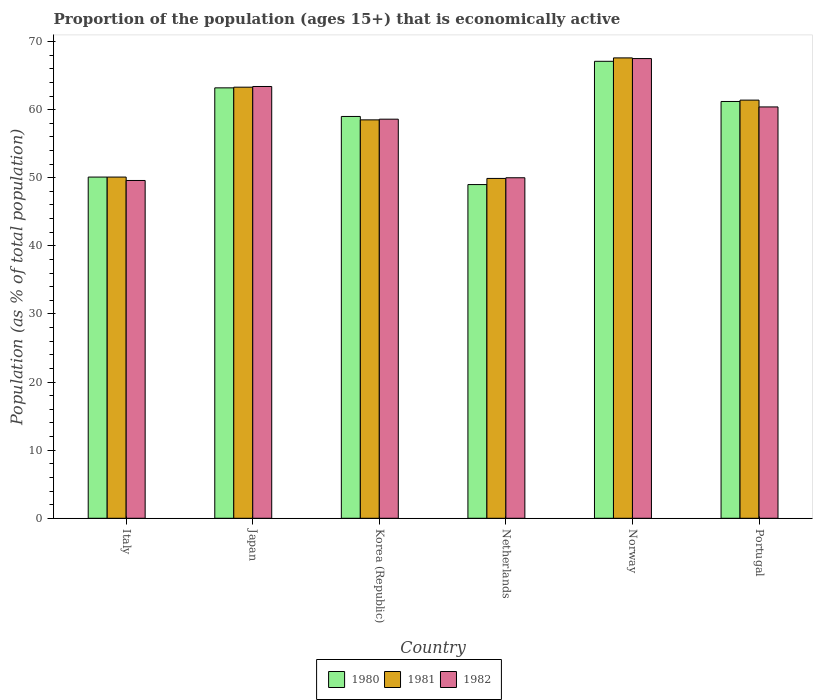How many groups of bars are there?
Offer a very short reply. 6. Are the number of bars on each tick of the X-axis equal?
Your answer should be compact. Yes. How many bars are there on the 1st tick from the left?
Provide a short and direct response. 3. What is the label of the 3rd group of bars from the left?
Ensure brevity in your answer.  Korea (Republic). In how many cases, is the number of bars for a given country not equal to the number of legend labels?
Provide a succinct answer. 0. Across all countries, what is the maximum proportion of the population that is economically active in 1982?
Offer a very short reply. 67.5. Across all countries, what is the minimum proportion of the population that is economically active in 1981?
Offer a very short reply. 49.9. What is the total proportion of the population that is economically active in 1982 in the graph?
Ensure brevity in your answer.  349.5. What is the difference between the proportion of the population that is economically active in 1981 in Italy and that in Netherlands?
Provide a short and direct response. 0.2. What is the difference between the proportion of the population that is economically active in 1982 in Netherlands and the proportion of the population that is economically active in 1980 in Norway?
Provide a succinct answer. -17.1. What is the average proportion of the population that is economically active in 1982 per country?
Your answer should be very brief. 58.25. What is the difference between the proportion of the population that is economically active of/in 1980 and proportion of the population that is economically active of/in 1981 in Japan?
Ensure brevity in your answer.  -0.1. In how many countries, is the proportion of the population that is economically active in 1982 greater than 44 %?
Make the answer very short. 6. What is the ratio of the proportion of the population that is economically active in 1982 in Italy to that in Norway?
Keep it short and to the point. 0.73. Is the difference between the proportion of the population that is economically active in 1980 in Italy and Netherlands greater than the difference between the proportion of the population that is economically active in 1981 in Italy and Netherlands?
Your answer should be very brief. Yes. What is the difference between the highest and the second highest proportion of the population that is economically active in 1980?
Provide a short and direct response. 5.9. What is the difference between the highest and the lowest proportion of the population that is economically active in 1982?
Keep it short and to the point. 17.9. Is it the case that in every country, the sum of the proportion of the population that is economically active in 1981 and proportion of the population that is economically active in 1982 is greater than the proportion of the population that is economically active in 1980?
Make the answer very short. Yes. How many bars are there?
Your response must be concise. 18. How many countries are there in the graph?
Your answer should be compact. 6. Are the values on the major ticks of Y-axis written in scientific E-notation?
Your answer should be compact. No. Does the graph contain any zero values?
Offer a terse response. No. Does the graph contain grids?
Provide a short and direct response. No. Where does the legend appear in the graph?
Keep it short and to the point. Bottom center. How many legend labels are there?
Your response must be concise. 3. How are the legend labels stacked?
Make the answer very short. Horizontal. What is the title of the graph?
Offer a terse response. Proportion of the population (ages 15+) that is economically active. What is the label or title of the X-axis?
Give a very brief answer. Country. What is the label or title of the Y-axis?
Your answer should be compact. Population (as % of total population). What is the Population (as % of total population) in 1980 in Italy?
Make the answer very short. 50.1. What is the Population (as % of total population) of 1981 in Italy?
Provide a succinct answer. 50.1. What is the Population (as % of total population) in 1982 in Italy?
Ensure brevity in your answer.  49.6. What is the Population (as % of total population) in 1980 in Japan?
Keep it short and to the point. 63.2. What is the Population (as % of total population) in 1981 in Japan?
Offer a terse response. 63.3. What is the Population (as % of total population) in 1982 in Japan?
Offer a very short reply. 63.4. What is the Population (as % of total population) in 1981 in Korea (Republic)?
Offer a very short reply. 58.5. What is the Population (as % of total population) in 1982 in Korea (Republic)?
Offer a terse response. 58.6. What is the Population (as % of total population) in 1980 in Netherlands?
Ensure brevity in your answer.  49. What is the Population (as % of total population) of 1981 in Netherlands?
Ensure brevity in your answer.  49.9. What is the Population (as % of total population) of 1980 in Norway?
Your answer should be compact. 67.1. What is the Population (as % of total population) in 1981 in Norway?
Your response must be concise. 67.6. What is the Population (as % of total population) in 1982 in Norway?
Give a very brief answer. 67.5. What is the Population (as % of total population) in 1980 in Portugal?
Give a very brief answer. 61.2. What is the Population (as % of total population) of 1981 in Portugal?
Make the answer very short. 61.4. What is the Population (as % of total population) in 1982 in Portugal?
Offer a terse response. 60.4. Across all countries, what is the maximum Population (as % of total population) in 1980?
Offer a very short reply. 67.1. Across all countries, what is the maximum Population (as % of total population) in 1981?
Your response must be concise. 67.6. Across all countries, what is the maximum Population (as % of total population) of 1982?
Your answer should be very brief. 67.5. Across all countries, what is the minimum Population (as % of total population) of 1980?
Give a very brief answer. 49. Across all countries, what is the minimum Population (as % of total population) in 1981?
Your answer should be compact. 49.9. Across all countries, what is the minimum Population (as % of total population) in 1982?
Provide a succinct answer. 49.6. What is the total Population (as % of total population) of 1980 in the graph?
Keep it short and to the point. 349.6. What is the total Population (as % of total population) in 1981 in the graph?
Offer a very short reply. 350.8. What is the total Population (as % of total population) of 1982 in the graph?
Keep it short and to the point. 349.5. What is the difference between the Population (as % of total population) of 1980 in Italy and that in Japan?
Keep it short and to the point. -13.1. What is the difference between the Population (as % of total population) in 1981 in Italy and that in Japan?
Provide a succinct answer. -13.2. What is the difference between the Population (as % of total population) of 1982 in Italy and that in Japan?
Ensure brevity in your answer.  -13.8. What is the difference between the Population (as % of total population) of 1981 in Italy and that in Korea (Republic)?
Provide a succinct answer. -8.4. What is the difference between the Population (as % of total population) in 1982 in Italy and that in Korea (Republic)?
Offer a terse response. -9. What is the difference between the Population (as % of total population) in 1980 in Italy and that in Netherlands?
Give a very brief answer. 1.1. What is the difference between the Population (as % of total population) in 1981 in Italy and that in Netherlands?
Your answer should be compact. 0.2. What is the difference between the Population (as % of total population) of 1982 in Italy and that in Netherlands?
Give a very brief answer. -0.4. What is the difference between the Population (as % of total population) in 1981 in Italy and that in Norway?
Your answer should be compact. -17.5. What is the difference between the Population (as % of total population) of 1982 in Italy and that in Norway?
Ensure brevity in your answer.  -17.9. What is the difference between the Population (as % of total population) in 1980 in Italy and that in Portugal?
Give a very brief answer. -11.1. What is the difference between the Population (as % of total population) in 1981 in Italy and that in Portugal?
Offer a terse response. -11.3. What is the difference between the Population (as % of total population) in 1980 in Japan and that in Netherlands?
Give a very brief answer. 14.2. What is the difference between the Population (as % of total population) of 1981 in Japan and that in Netherlands?
Keep it short and to the point. 13.4. What is the difference between the Population (as % of total population) in 1982 in Japan and that in Netherlands?
Provide a succinct answer. 13.4. What is the difference between the Population (as % of total population) in 1981 in Japan and that in Norway?
Your response must be concise. -4.3. What is the difference between the Population (as % of total population) in 1980 in Japan and that in Portugal?
Make the answer very short. 2. What is the difference between the Population (as % of total population) in 1980 in Korea (Republic) and that in Netherlands?
Your answer should be compact. 10. What is the difference between the Population (as % of total population) in 1981 in Korea (Republic) and that in Netherlands?
Your answer should be very brief. 8.6. What is the difference between the Population (as % of total population) of 1982 in Korea (Republic) and that in Netherlands?
Offer a very short reply. 8.6. What is the difference between the Population (as % of total population) in 1981 in Korea (Republic) and that in Norway?
Your answer should be very brief. -9.1. What is the difference between the Population (as % of total population) of 1982 in Korea (Republic) and that in Norway?
Keep it short and to the point. -8.9. What is the difference between the Population (as % of total population) of 1980 in Korea (Republic) and that in Portugal?
Your answer should be very brief. -2.2. What is the difference between the Population (as % of total population) in 1981 in Korea (Republic) and that in Portugal?
Offer a terse response. -2.9. What is the difference between the Population (as % of total population) of 1980 in Netherlands and that in Norway?
Ensure brevity in your answer.  -18.1. What is the difference between the Population (as % of total population) of 1981 in Netherlands and that in Norway?
Your answer should be very brief. -17.7. What is the difference between the Population (as % of total population) in 1982 in Netherlands and that in Norway?
Your answer should be compact. -17.5. What is the difference between the Population (as % of total population) of 1980 in Netherlands and that in Portugal?
Offer a terse response. -12.2. What is the difference between the Population (as % of total population) in 1981 in Netherlands and that in Portugal?
Your answer should be compact. -11.5. What is the difference between the Population (as % of total population) of 1981 in Norway and that in Portugal?
Keep it short and to the point. 6.2. What is the difference between the Population (as % of total population) of 1980 in Italy and the Population (as % of total population) of 1981 in Korea (Republic)?
Offer a very short reply. -8.4. What is the difference between the Population (as % of total population) in 1980 in Italy and the Population (as % of total population) in 1981 in Netherlands?
Offer a very short reply. 0.2. What is the difference between the Population (as % of total population) in 1980 in Italy and the Population (as % of total population) in 1981 in Norway?
Make the answer very short. -17.5. What is the difference between the Population (as % of total population) of 1980 in Italy and the Population (as % of total population) of 1982 in Norway?
Offer a very short reply. -17.4. What is the difference between the Population (as % of total population) of 1981 in Italy and the Population (as % of total population) of 1982 in Norway?
Keep it short and to the point. -17.4. What is the difference between the Population (as % of total population) of 1980 in Italy and the Population (as % of total population) of 1981 in Portugal?
Make the answer very short. -11.3. What is the difference between the Population (as % of total population) in 1980 in Japan and the Population (as % of total population) in 1981 in Korea (Republic)?
Provide a succinct answer. 4.7. What is the difference between the Population (as % of total population) of 1981 in Japan and the Population (as % of total population) of 1982 in Netherlands?
Your answer should be compact. 13.3. What is the difference between the Population (as % of total population) of 1980 in Japan and the Population (as % of total population) of 1982 in Norway?
Ensure brevity in your answer.  -4.3. What is the difference between the Population (as % of total population) in 1981 in Japan and the Population (as % of total population) in 1982 in Portugal?
Give a very brief answer. 2.9. What is the difference between the Population (as % of total population) in 1980 in Korea (Republic) and the Population (as % of total population) in 1981 in Netherlands?
Offer a terse response. 9.1. What is the difference between the Population (as % of total population) in 1980 in Korea (Republic) and the Population (as % of total population) in 1982 in Netherlands?
Offer a terse response. 9. What is the difference between the Population (as % of total population) of 1981 in Korea (Republic) and the Population (as % of total population) of 1982 in Netherlands?
Provide a short and direct response. 8.5. What is the difference between the Population (as % of total population) in 1980 in Korea (Republic) and the Population (as % of total population) in 1981 in Portugal?
Keep it short and to the point. -2.4. What is the difference between the Population (as % of total population) of 1981 in Korea (Republic) and the Population (as % of total population) of 1982 in Portugal?
Your answer should be compact. -1.9. What is the difference between the Population (as % of total population) in 1980 in Netherlands and the Population (as % of total population) in 1981 in Norway?
Provide a short and direct response. -18.6. What is the difference between the Population (as % of total population) of 1980 in Netherlands and the Population (as % of total population) of 1982 in Norway?
Offer a very short reply. -18.5. What is the difference between the Population (as % of total population) in 1981 in Netherlands and the Population (as % of total population) in 1982 in Norway?
Provide a succinct answer. -17.6. What is the difference between the Population (as % of total population) of 1980 in Netherlands and the Population (as % of total population) of 1981 in Portugal?
Make the answer very short. -12.4. What is the difference between the Population (as % of total population) in 1981 in Netherlands and the Population (as % of total population) in 1982 in Portugal?
Keep it short and to the point. -10.5. What is the difference between the Population (as % of total population) of 1981 in Norway and the Population (as % of total population) of 1982 in Portugal?
Your response must be concise. 7.2. What is the average Population (as % of total population) in 1980 per country?
Your answer should be compact. 58.27. What is the average Population (as % of total population) of 1981 per country?
Your response must be concise. 58.47. What is the average Population (as % of total population) in 1982 per country?
Keep it short and to the point. 58.25. What is the difference between the Population (as % of total population) in 1980 and Population (as % of total population) in 1982 in Italy?
Offer a very short reply. 0.5. What is the difference between the Population (as % of total population) of 1980 and Population (as % of total population) of 1981 in Japan?
Your response must be concise. -0.1. What is the difference between the Population (as % of total population) of 1981 and Population (as % of total population) of 1982 in Japan?
Give a very brief answer. -0.1. What is the difference between the Population (as % of total population) of 1980 and Population (as % of total population) of 1981 in Korea (Republic)?
Your answer should be compact. 0.5. What is the difference between the Population (as % of total population) of 1981 and Population (as % of total population) of 1982 in Korea (Republic)?
Your answer should be very brief. -0.1. What is the difference between the Population (as % of total population) in 1980 and Population (as % of total population) in 1981 in Netherlands?
Give a very brief answer. -0.9. What is the difference between the Population (as % of total population) in 1981 and Population (as % of total population) in 1982 in Netherlands?
Make the answer very short. -0.1. What is the difference between the Population (as % of total population) of 1980 and Population (as % of total population) of 1982 in Norway?
Your response must be concise. -0.4. What is the difference between the Population (as % of total population) in 1980 and Population (as % of total population) in 1982 in Portugal?
Offer a terse response. 0.8. What is the difference between the Population (as % of total population) of 1981 and Population (as % of total population) of 1982 in Portugal?
Offer a terse response. 1. What is the ratio of the Population (as % of total population) in 1980 in Italy to that in Japan?
Your answer should be very brief. 0.79. What is the ratio of the Population (as % of total population) in 1981 in Italy to that in Japan?
Provide a short and direct response. 0.79. What is the ratio of the Population (as % of total population) in 1982 in Italy to that in Japan?
Keep it short and to the point. 0.78. What is the ratio of the Population (as % of total population) in 1980 in Italy to that in Korea (Republic)?
Provide a succinct answer. 0.85. What is the ratio of the Population (as % of total population) of 1981 in Italy to that in Korea (Republic)?
Make the answer very short. 0.86. What is the ratio of the Population (as % of total population) of 1982 in Italy to that in Korea (Republic)?
Provide a succinct answer. 0.85. What is the ratio of the Population (as % of total population) in 1980 in Italy to that in Netherlands?
Your answer should be compact. 1.02. What is the ratio of the Population (as % of total population) in 1982 in Italy to that in Netherlands?
Provide a succinct answer. 0.99. What is the ratio of the Population (as % of total population) in 1980 in Italy to that in Norway?
Keep it short and to the point. 0.75. What is the ratio of the Population (as % of total population) in 1981 in Italy to that in Norway?
Your response must be concise. 0.74. What is the ratio of the Population (as % of total population) in 1982 in Italy to that in Norway?
Ensure brevity in your answer.  0.73. What is the ratio of the Population (as % of total population) in 1980 in Italy to that in Portugal?
Your answer should be very brief. 0.82. What is the ratio of the Population (as % of total population) of 1981 in Italy to that in Portugal?
Keep it short and to the point. 0.82. What is the ratio of the Population (as % of total population) in 1982 in Italy to that in Portugal?
Your response must be concise. 0.82. What is the ratio of the Population (as % of total population) in 1980 in Japan to that in Korea (Republic)?
Make the answer very short. 1.07. What is the ratio of the Population (as % of total population) of 1981 in Japan to that in Korea (Republic)?
Keep it short and to the point. 1.08. What is the ratio of the Population (as % of total population) in 1982 in Japan to that in Korea (Republic)?
Provide a succinct answer. 1.08. What is the ratio of the Population (as % of total population) in 1980 in Japan to that in Netherlands?
Provide a short and direct response. 1.29. What is the ratio of the Population (as % of total population) of 1981 in Japan to that in Netherlands?
Make the answer very short. 1.27. What is the ratio of the Population (as % of total population) of 1982 in Japan to that in Netherlands?
Your answer should be very brief. 1.27. What is the ratio of the Population (as % of total population) of 1980 in Japan to that in Norway?
Ensure brevity in your answer.  0.94. What is the ratio of the Population (as % of total population) in 1981 in Japan to that in Norway?
Your response must be concise. 0.94. What is the ratio of the Population (as % of total population) in 1982 in Japan to that in Norway?
Provide a short and direct response. 0.94. What is the ratio of the Population (as % of total population) in 1980 in Japan to that in Portugal?
Ensure brevity in your answer.  1.03. What is the ratio of the Population (as % of total population) of 1981 in Japan to that in Portugal?
Give a very brief answer. 1.03. What is the ratio of the Population (as % of total population) in 1982 in Japan to that in Portugal?
Your answer should be compact. 1.05. What is the ratio of the Population (as % of total population) of 1980 in Korea (Republic) to that in Netherlands?
Offer a very short reply. 1.2. What is the ratio of the Population (as % of total population) in 1981 in Korea (Republic) to that in Netherlands?
Provide a succinct answer. 1.17. What is the ratio of the Population (as % of total population) in 1982 in Korea (Republic) to that in Netherlands?
Ensure brevity in your answer.  1.17. What is the ratio of the Population (as % of total population) of 1980 in Korea (Republic) to that in Norway?
Your answer should be compact. 0.88. What is the ratio of the Population (as % of total population) in 1981 in Korea (Republic) to that in Norway?
Offer a very short reply. 0.87. What is the ratio of the Population (as % of total population) in 1982 in Korea (Republic) to that in Norway?
Provide a succinct answer. 0.87. What is the ratio of the Population (as % of total population) in 1980 in Korea (Republic) to that in Portugal?
Your answer should be compact. 0.96. What is the ratio of the Population (as % of total population) of 1981 in Korea (Republic) to that in Portugal?
Provide a succinct answer. 0.95. What is the ratio of the Population (as % of total population) of 1982 in Korea (Republic) to that in Portugal?
Your answer should be compact. 0.97. What is the ratio of the Population (as % of total population) of 1980 in Netherlands to that in Norway?
Your response must be concise. 0.73. What is the ratio of the Population (as % of total population) in 1981 in Netherlands to that in Norway?
Provide a short and direct response. 0.74. What is the ratio of the Population (as % of total population) in 1982 in Netherlands to that in Norway?
Give a very brief answer. 0.74. What is the ratio of the Population (as % of total population) in 1980 in Netherlands to that in Portugal?
Give a very brief answer. 0.8. What is the ratio of the Population (as % of total population) of 1981 in Netherlands to that in Portugal?
Provide a short and direct response. 0.81. What is the ratio of the Population (as % of total population) of 1982 in Netherlands to that in Portugal?
Offer a very short reply. 0.83. What is the ratio of the Population (as % of total population) of 1980 in Norway to that in Portugal?
Offer a very short reply. 1.1. What is the ratio of the Population (as % of total population) in 1981 in Norway to that in Portugal?
Make the answer very short. 1.1. What is the ratio of the Population (as % of total population) of 1982 in Norway to that in Portugal?
Your answer should be very brief. 1.12. What is the difference between the highest and the second highest Population (as % of total population) of 1981?
Your answer should be very brief. 4.3. 